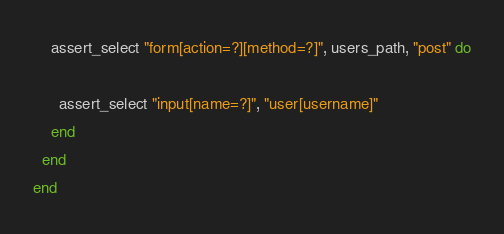<code> <loc_0><loc_0><loc_500><loc_500><_Ruby_>
    assert_select "form[action=?][method=?]", users_path, "post" do

      assert_select "input[name=?]", "user[username]"
    end
  end
end
</code> 